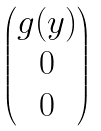Convert formula to latex. <formula><loc_0><loc_0><loc_500><loc_500>\begin{pmatrix} g ( y ) \\ 0 \\ 0 \end{pmatrix}</formula> 